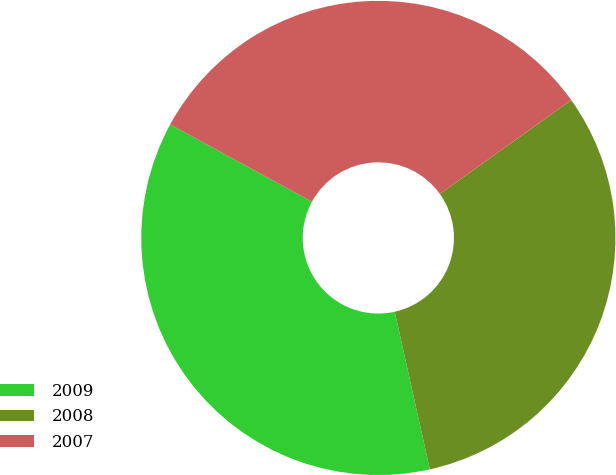Convert chart. <chart><loc_0><loc_0><loc_500><loc_500><pie_chart><fcel>2009<fcel>2008<fcel>2007<nl><fcel>36.43%<fcel>31.39%<fcel>32.18%<nl></chart> 